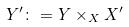Convert formula to latex. <formula><loc_0><loc_0><loc_500><loc_500>Y ^ { \prime } \colon = Y \times _ { X } X ^ { \prime }</formula> 